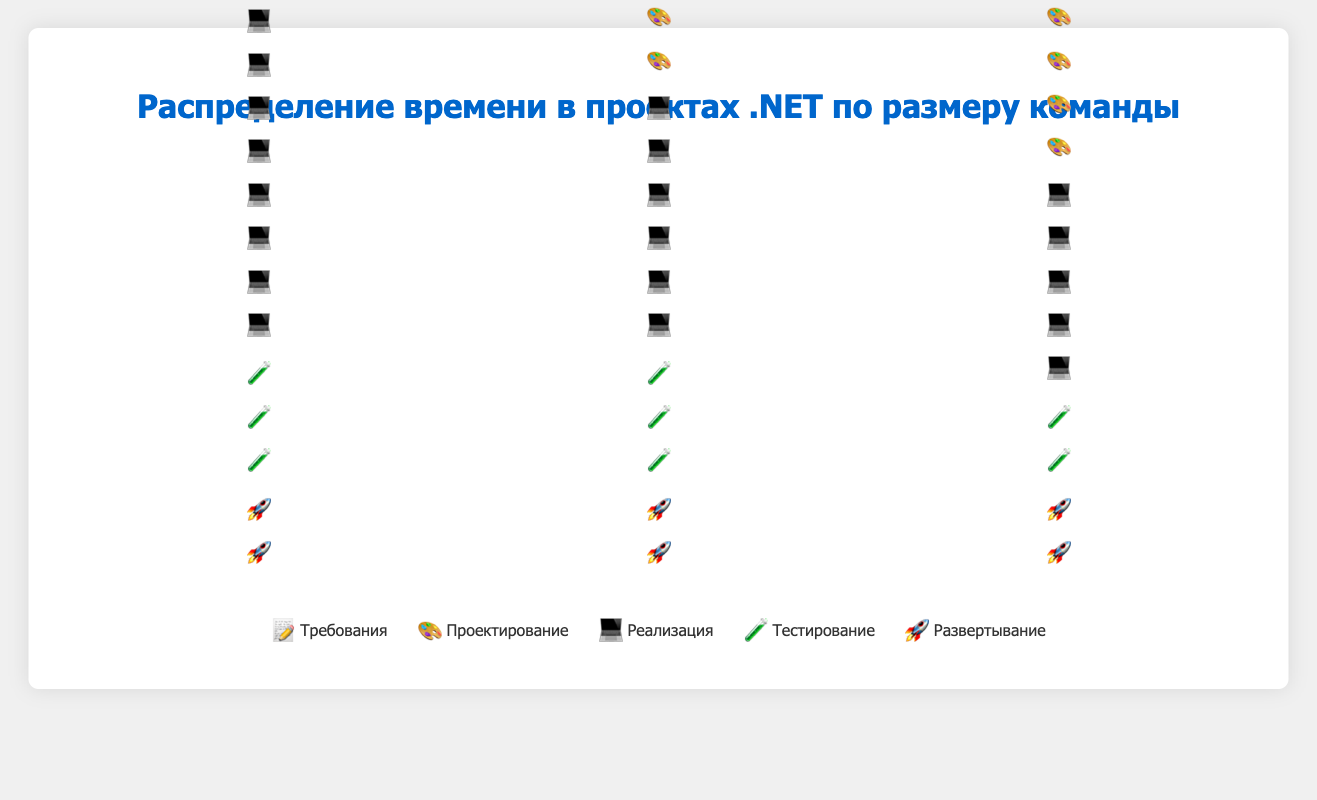What is the percentage of time allocated to the Requirements phase for a large team? According to the figure, the Requirements phase is represented by five 📝 icons for a large team. Each icon represents 5%, summing up to 25%.
Answer: 25% Which team size spends the most time on the Design phase? By observing the figure, the large team has the most 🎨 icons for the Design phase, with a total of 6 icons, representing 30%. This is higher than the number of icons for small and medium teams.
Answer: Large (16+) How much more time does a small team spend on Implementation compared to a medium team? The small team has 8 💻 icons for Implementation, whereas the medium team has 6 💻 icons. Each icon represents 5%, so the small team spends 10% more time (40% - 30% = 10%).
Answer: 10% What percentage of time do medium and large teams allocate to Testing combined? The medium team allocates 15% and the large team allocates 10% to Testing. Combined, this is 15% + 10% = 25%.
Answer: 25% For which team size is the proportion of time spent on Deployment the same? All the team sizes (small, medium, and large) allocate the same percentage to Deployment, represented by two 🚀 icons each, which translates to 10%.
Answer: All team sizes How does the allocation of time to the Testing phase change as team size increases? The figure shows that the number of 🧪 icons decreases as team size increases: small (3 icons), medium (3 icons), and large (2 icons). This indicates that smaller teams allocate more time to Testing compared to larger teams.
Answer: It decreases Which phase has the smallest range of allocated time percentages across different team sizes? All team sizes allocate the same percentage to the Deployment phase (10%), thus the range is 0%.
Answer: Deployment 